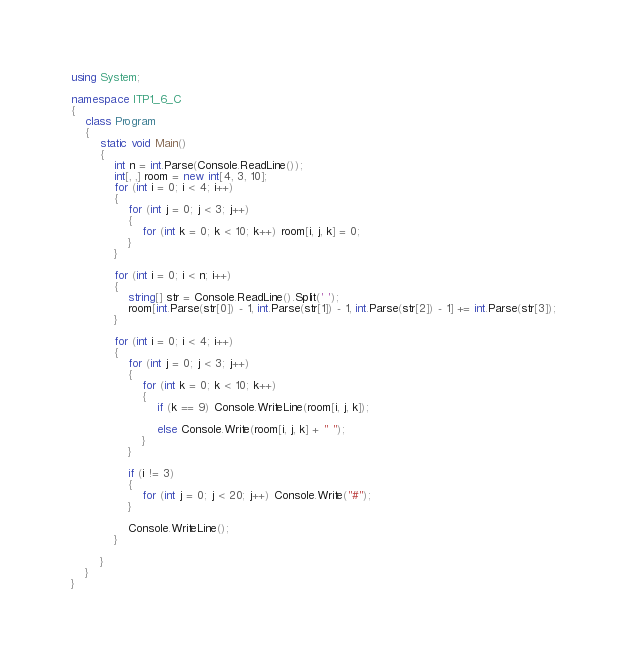<code> <loc_0><loc_0><loc_500><loc_500><_C#_>using System;

namespace ITP1_6_C
{
    class Program
    {
        static void Main()
        {
            int n = int.Parse(Console.ReadLine());
            int[, ,] room = new int[4, 3, 10];
            for (int i = 0; i < 4; i++)
            {
                for (int j = 0; j < 3; j++)
                {
                    for (int k = 0; k < 10; k++) room[i, j, k] = 0;
                }
            }

            for (int i = 0; i < n; i++)
            {
                string[] str = Console.ReadLine().Split(' ');
                room[int.Parse(str[0]) - 1, int.Parse(str[1]) - 1, int.Parse(str[2]) - 1] += int.Parse(str[3]);
            }

            for (int i = 0; i < 4; i++)
            {
                for (int j = 0; j < 3; j++)
                {
                    for (int k = 0; k < 10; k++)
                    {
                        if (k == 9) Console.WriteLine(room[i, j, k]);

                        else Console.Write(room[i, j, k] + " ");
                    }
                }

                if (i != 3)
                {
                    for (int j = 0; j < 20; j++) Console.Write("#");
                }

                Console.WriteLine();
            }

        }
    }
}</code> 